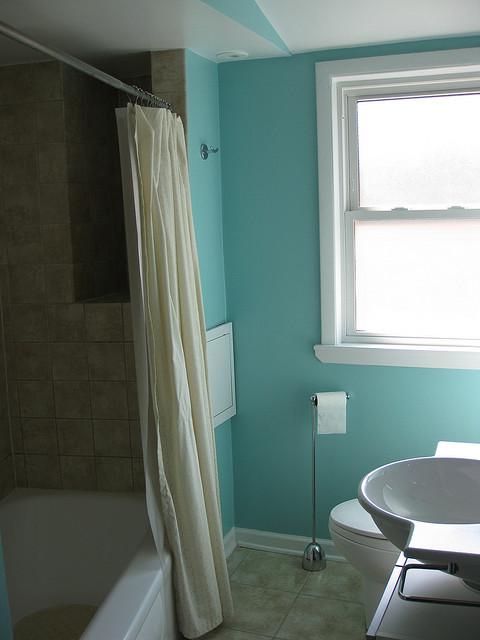How many tissues are there?
Be succinct. 1. What room is this?
Answer briefly. Bathroom. What color is the tissue roll?
Keep it brief. White. 